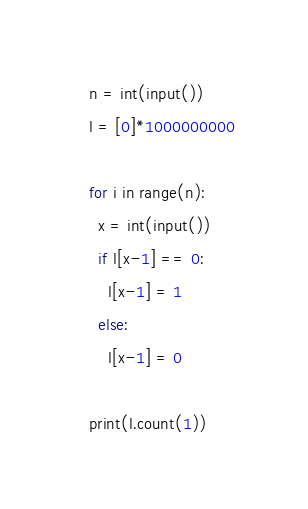Convert code to text. <code><loc_0><loc_0><loc_500><loc_500><_Python_>n = int(input())
l = [0]*1000000000

for i in range(n):
  x = int(input())
  if l[x-1] == 0:
    l[x-1] = 1
  else:
    l[x-1] = 0

print(l.count(1))</code> 